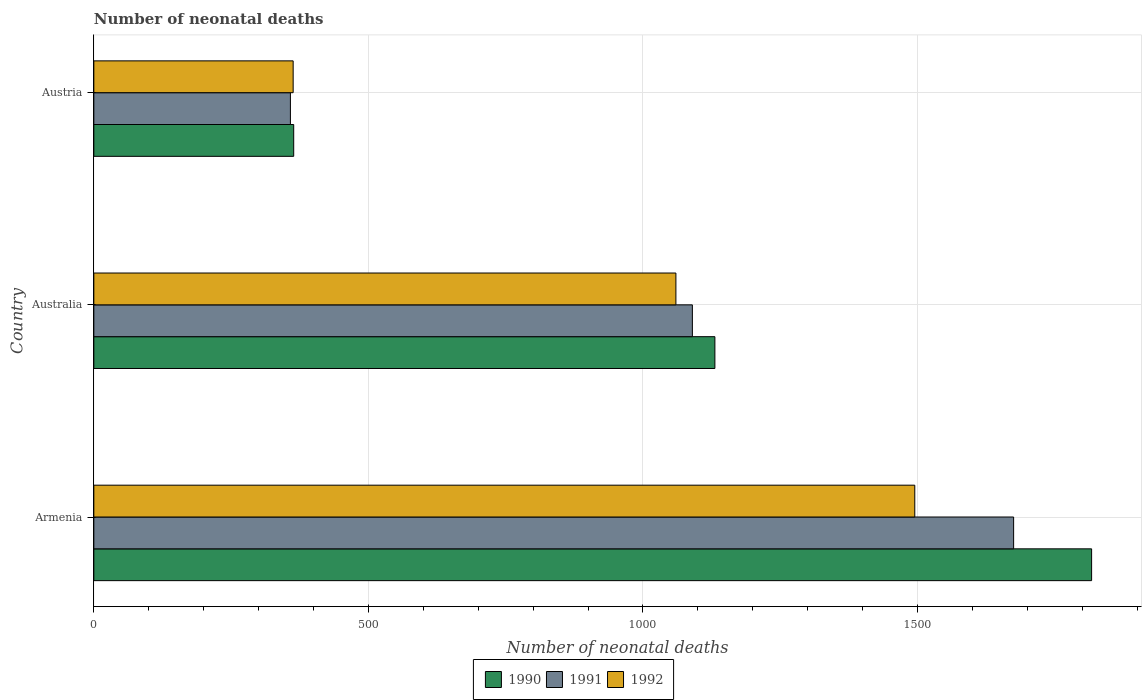How many different coloured bars are there?
Offer a terse response. 3. How many groups of bars are there?
Ensure brevity in your answer.  3. Are the number of bars per tick equal to the number of legend labels?
Offer a terse response. Yes. Are the number of bars on each tick of the Y-axis equal?
Your answer should be compact. Yes. How many bars are there on the 3rd tick from the top?
Provide a short and direct response. 3. How many bars are there on the 3rd tick from the bottom?
Your response must be concise. 3. What is the label of the 3rd group of bars from the top?
Provide a succinct answer. Armenia. In how many cases, is the number of bars for a given country not equal to the number of legend labels?
Ensure brevity in your answer.  0. What is the number of neonatal deaths in in 1991 in Armenia?
Ensure brevity in your answer.  1675. Across all countries, what is the maximum number of neonatal deaths in in 1992?
Offer a terse response. 1495. Across all countries, what is the minimum number of neonatal deaths in in 1992?
Your answer should be compact. 363. In which country was the number of neonatal deaths in in 1991 maximum?
Offer a terse response. Armenia. In which country was the number of neonatal deaths in in 1990 minimum?
Ensure brevity in your answer.  Austria. What is the total number of neonatal deaths in in 1990 in the graph?
Offer a very short reply. 3312. What is the difference between the number of neonatal deaths in in 1991 in Australia and that in Austria?
Ensure brevity in your answer.  732. What is the difference between the number of neonatal deaths in in 1991 in Armenia and the number of neonatal deaths in in 1992 in Austria?
Keep it short and to the point. 1312. What is the average number of neonatal deaths in in 1991 per country?
Provide a succinct answer. 1041. What is the difference between the number of neonatal deaths in in 1992 and number of neonatal deaths in in 1990 in Australia?
Provide a short and direct response. -71. In how many countries, is the number of neonatal deaths in in 1990 greater than 1000 ?
Offer a terse response. 2. What is the ratio of the number of neonatal deaths in in 1990 in Armenia to that in Austria?
Keep it short and to the point. 4.99. Is the difference between the number of neonatal deaths in in 1992 in Armenia and Austria greater than the difference between the number of neonatal deaths in in 1990 in Armenia and Austria?
Keep it short and to the point. No. What is the difference between the highest and the second highest number of neonatal deaths in in 1990?
Ensure brevity in your answer.  686. What is the difference between the highest and the lowest number of neonatal deaths in in 1990?
Your response must be concise. 1453. What does the 3rd bar from the bottom in Australia represents?
Make the answer very short. 1992. How many bars are there?
Make the answer very short. 9. Are all the bars in the graph horizontal?
Ensure brevity in your answer.  Yes. How many countries are there in the graph?
Make the answer very short. 3. What is the difference between two consecutive major ticks on the X-axis?
Ensure brevity in your answer.  500. Where does the legend appear in the graph?
Provide a short and direct response. Bottom center. How many legend labels are there?
Ensure brevity in your answer.  3. How are the legend labels stacked?
Offer a terse response. Horizontal. What is the title of the graph?
Offer a very short reply. Number of neonatal deaths. Does "1970" appear as one of the legend labels in the graph?
Offer a very short reply. No. What is the label or title of the X-axis?
Offer a terse response. Number of neonatal deaths. What is the Number of neonatal deaths of 1990 in Armenia?
Keep it short and to the point. 1817. What is the Number of neonatal deaths in 1991 in Armenia?
Your response must be concise. 1675. What is the Number of neonatal deaths of 1992 in Armenia?
Provide a succinct answer. 1495. What is the Number of neonatal deaths of 1990 in Australia?
Your answer should be compact. 1131. What is the Number of neonatal deaths in 1991 in Australia?
Give a very brief answer. 1090. What is the Number of neonatal deaths of 1992 in Australia?
Ensure brevity in your answer.  1060. What is the Number of neonatal deaths in 1990 in Austria?
Provide a short and direct response. 364. What is the Number of neonatal deaths of 1991 in Austria?
Make the answer very short. 358. What is the Number of neonatal deaths in 1992 in Austria?
Make the answer very short. 363. Across all countries, what is the maximum Number of neonatal deaths in 1990?
Your answer should be very brief. 1817. Across all countries, what is the maximum Number of neonatal deaths of 1991?
Provide a short and direct response. 1675. Across all countries, what is the maximum Number of neonatal deaths in 1992?
Provide a short and direct response. 1495. Across all countries, what is the minimum Number of neonatal deaths of 1990?
Provide a short and direct response. 364. Across all countries, what is the minimum Number of neonatal deaths in 1991?
Offer a terse response. 358. Across all countries, what is the minimum Number of neonatal deaths of 1992?
Ensure brevity in your answer.  363. What is the total Number of neonatal deaths in 1990 in the graph?
Provide a succinct answer. 3312. What is the total Number of neonatal deaths of 1991 in the graph?
Your answer should be compact. 3123. What is the total Number of neonatal deaths in 1992 in the graph?
Your answer should be very brief. 2918. What is the difference between the Number of neonatal deaths of 1990 in Armenia and that in Australia?
Your response must be concise. 686. What is the difference between the Number of neonatal deaths of 1991 in Armenia and that in Australia?
Ensure brevity in your answer.  585. What is the difference between the Number of neonatal deaths in 1992 in Armenia and that in Australia?
Keep it short and to the point. 435. What is the difference between the Number of neonatal deaths of 1990 in Armenia and that in Austria?
Your answer should be compact. 1453. What is the difference between the Number of neonatal deaths in 1991 in Armenia and that in Austria?
Make the answer very short. 1317. What is the difference between the Number of neonatal deaths of 1992 in Armenia and that in Austria?
Your answer should be very brief. 1132. What is the difference between the Number of neonatal deaths of 1990 in Australia and that in Austria?
Provide a succinct answer. 767. What is the difference between the Number of neonatal deaths of 1991 in Australia and that in Austria?
Provide a short and direct response. 732. What is the difference between the Number of neonatal deaths of 1992 in Australia and that in Austria?
Your answer should be very brief. 697. What is the difference between the Number of neonatal deaths in 1990 in Armenia and the Number of neonatal deaths in 1991 in Australia?
Your response must be concise. 727. What is the difference between the Number of neonatal deaths in 1990 in Armenia and the Number of neonatal deaths in 1992 in Australia?
Give a very brief answer. 757. What is the difference between the Number of neonatal deaths in 1991 in Armenia and the Number of neonatal deaths in 1992 in Australia?
Give a very brief answer. 615. What is the difference between the Number of neonatal deaths in 1990 in Armenia and the Number of neonatal deaths in 1991 in Austria?
Offer a very short reply. 1459. What is the difference between the Number of neonatal deaths of 1990 in Armenia and the Number of neonatal deaths of 1992 in Austria?
Give a very brief answer. 1454. What is the difference between the Number of neonatal deaths in 1991 in Armenia and the Number of neonatal deaths in 1992 in Austria?
Provide a short and direct response. 1312. What is the difference between the Number of neonatal deaths of 1990 in Australia and the Number of neonatal deaths of 1991 in Austria?
Keep it short and to the point. 773. What is the difference between the Number of neonatal deaths of 1990 in Australia and the Number of neonatal deaths of 1992 in Austria?
Give a very brief answer. 768. What is the difference between the Number of neonatal deaths in 1991 in Australia and the Number of neonatal deaths in 1992 in Austria?
Provide a succinct answer. 727. What is the average Number of neonatal deaths in 1990 per country?
Provide a succinct answer. 1104. What is the average Number of neonatal deaths in 1991 per country?
Ensure brevity in your answer.  1041. What is the average Number of neonatal deaths in 1992 per country?
Make the answer very short. 972.67. What is the difference between the Number of neonatal deaths in 1990 and Number of neonatal deaths in 1991 in Armenia?
Ensure brevity in your answer.  142. What is the difference between the Number of neonatal deaths in 1990 and Number of neonatal deaths in 1992 in Armenia?
Give a very brief answer. 322. What is the difference between the Number of neonatal deaths of 1991 and Number of neonatal deaths of 1992 in Armenia?
Make the answer very short. 180. What is the difference between the Number of neonatal deaths in 1990 and Number of neonatal deaths in 1991 in Austria?
Give a very brief answer. 6. What is the difference between the Number of neonatal deaths of 1990 and Number of neonatal deaths of 1992 in Austria?
Provide a short and direct response. 1. What is the ratio of the Number of neonatal deaths in 1990 in Armenia to that in Australia?
Your answer should be very brief. 1.61. What is the ratio of the Number of neonatal deaths in 1991 in Armenia to that in Australia?
Your response must be concise. 1.54. What is the ratio of the Number of neonatal deaths of 1992 in Armenia to that in Australia?
Ensure brevity in your answer.  1.41. What is the ratio of the Number of neonatal deaths in 1990 in Armenia to that in Austria?
Ensure brevity in your answer.  4.99. What is the ratio of the Number of neonatal deaths in 1991 in Armenia to that in Austria?
Your answer should be very brief. 4.68. What is the ratio of the Number of neonatal deaths of 1992 in Armenia to that in Austria?
Your answer should be compact. 4.12. What is the ratio of the Number of neonatal deaths in 1990 in Australia to that in Austria?
Keep it short and to the point. 3.11. What is the ratio of the Number of neonatal deaths in 1991 in Australia to that in Austria?
Ensure brevity in your answer.  3.04. What is the ratio of the Number of neonatal deaths in 1992 in Australia to that in Austria?
Ensure brevity in your answer.  2.92. What is the difference between the highest and the second highest Number of neonatal deaths of 1990?
Make the answer very short. 686. What is the difference between the highest and the second highest Number of neonatal deaths of 1991?
Your answer should be very brief. 585. What is the difference between the highest and the second highest Number of neonatal deaths of 1992?
Your answer should be compact. 435. What is the difference between the highest and the lowest Number of neonatal deaths in 1990?
Your answer should be compact. 1453. What is the difference between the highest and the lowest Number of neonatal deaths of 1991?
Offer a terse response. 1317. What is the difference between the highest and the lowest Number of neonatal deaths in 1992?
Keep it short and to the point. 1132. 